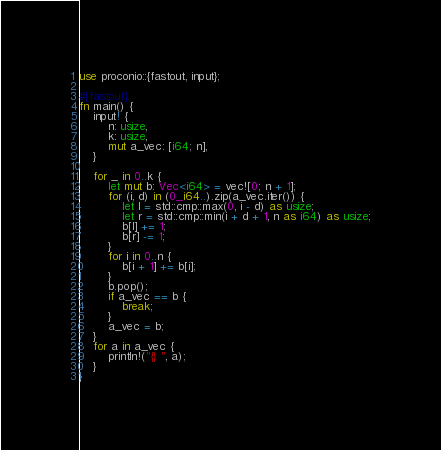Convert code to text. <code><loc_0><loc_0><loc_500><loc_500><_Rust_>use proconio::{fastout, input};

#[fastout]
fn main() {
    input! {
        n: usize,
        k: usize,
        mut a_vec: [i64; n],
    }

    for _ in 0..k {
        let mut b: Vec<i64> = vec![0; n + 1];
        for (i, d) in (0_i64..).zip(a_vec.iter()) {
            let l = std::cmp::max(0, i - d) as usize;
            let r = std::cmp::min(i + d + 1, n as i64) as usize;
            b[l] += 1;
            b[r] -= 1;
        }
        for i in 0..n {
            b[i + 1] += b[i];
        }
        b.pop();
        if a_vec == b {
            break;
        }
        a_vec = b;
    }
    for a in a_vec {
        println!("{} ", a);
    }
}
</code> 